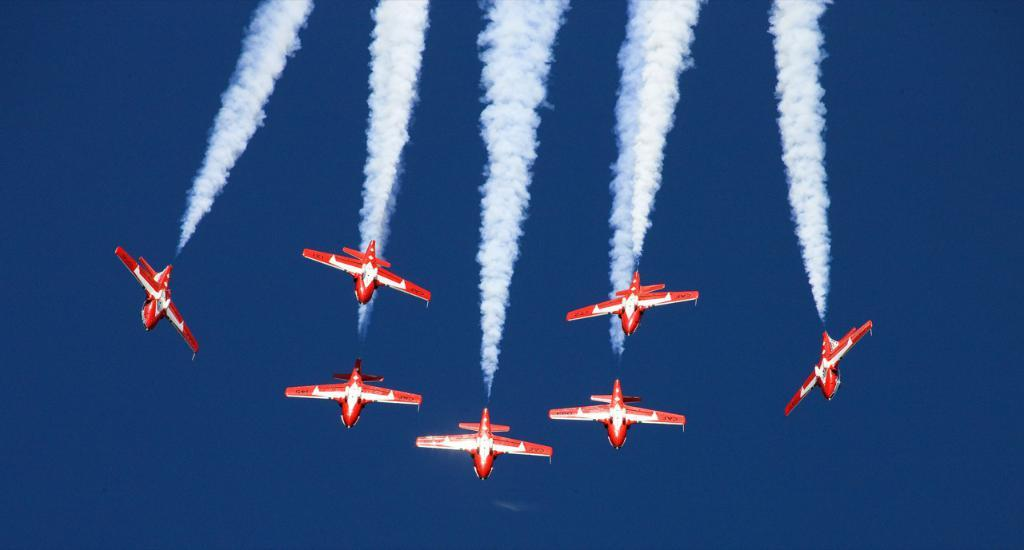What color are the aircraft in the image? The aircraft in the image are red. What are the aircraft doing in the image? The aircraft are flying in the sky. What is coming out of the aircraft in the image? The aircraft are emitting smoke. What type of brass material can be seen on the aircraft in the image? There is no brass material visible on the aircraft in the image. How does the quartz affect the performance of the aircraft in the image? There is no quartz present in the image, so its effect on the aircraft's performance cannot be determined. 